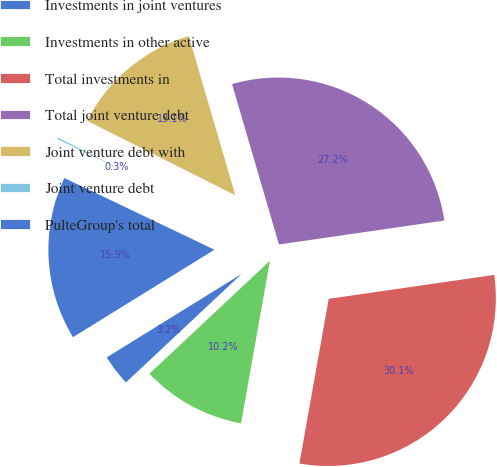Convert chart to OTSL. <chart><loc_0><loc_0><loc_500><loc_500><pie_chart><fcel>Investments in joint ventures<fcel>Investments in other active<fcel>Total investments in<fcel>Total joint venture debt<fcel>Joint venture debt with<fcel>Joint venture debt<fcel>PulteGroup's total<nl><fcel>3.17%<fcel>10.21%<fcel>30.09%<fcel>27.24%<fcel>13.06%<fcel>0.32%<fcel>15.91%<nl></chart> 